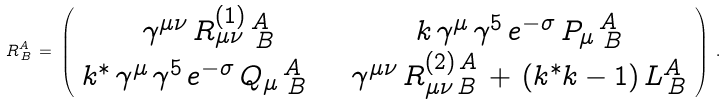Convert formula to latex. <formula><loc_0><loc_0><loc_500><loc_500>R _ { \, B } ^ { A } \, = \, \left ( \begin{array} { c c } { { \gamma ^ { \mu \nu } \, R _ { \mu \nu } ^ { ( 1 ) } \, _ { \, B } ^ { A } } } & { { k \, \gamma ^ { \mu } \, \gamma ^ { 5 } \, e ^ { - \sigma } \, P _ { \mu } \, _ { \, B } ^ { A } } } \\ { { k ^ { * } \, \gamma ^ { \mu } \, \gamma ^ { 5 } \, e ^ { - \sigma } \, Q _ { \mu } \, _ { \, B } ^ { A } \quad } } & { { \gamma ^ { \mu \nu } \, R _ { \mu \nu \, B } ^ { ( 2 ) \, A } \, + \, ( k ^ { * } k - 1 ) \, L _ { \, B } ^ { A } } } \end{array} \right ) \, .</formula> 